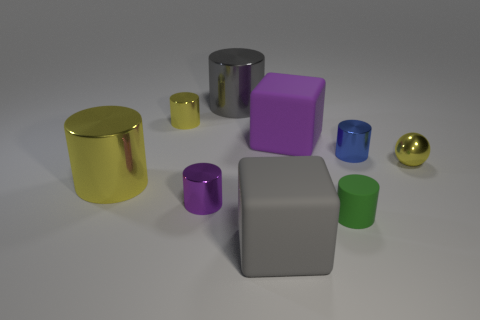Subtract all big gray cylinders. How many cylinders are left? 5 Add 1 big gray objects. How many objects exist? 10 Subtract all purple blocks. How many blocks are left? 1 Subtract all cubes. How many objects are left? 7 Subtract 0 purple spheres. How many objects are left? 9 Subtract 1 spheres. How many spheres are left? 0 Subtract all brown cylinders. Subtract all brown blocks. How many cylinders are left? 6 Subtract all brown balls. How many brown blocks are left? 0 Subtract all small objects. Subtract all small cyan rubber cubes. How many objects are left? 4 Add 5 large gray blocks. How many large gray blocks are left? 6 